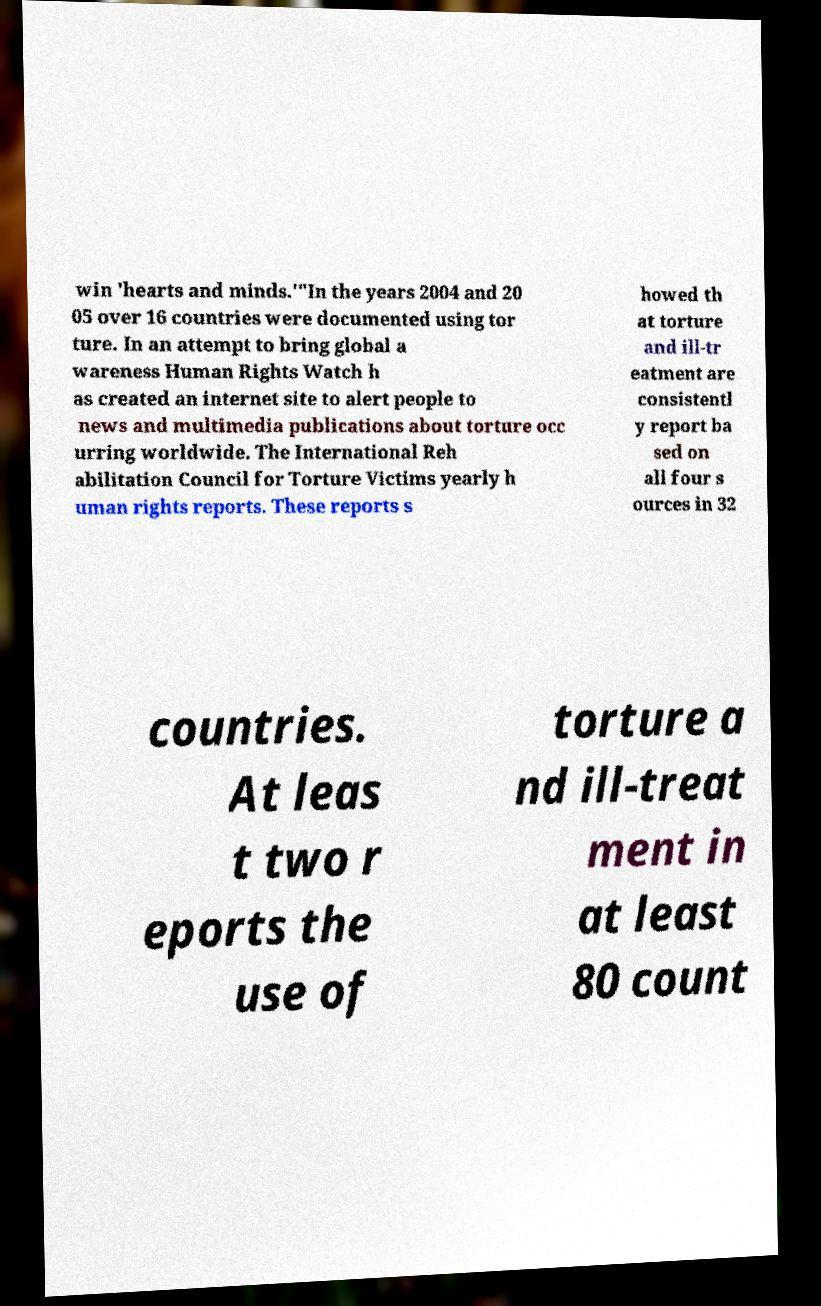Can you read and provide the text displayed in the image?This photo seems to have some interesting text. Can you extract and type it out for me? win 'hearts and minds.'"In the years 2004 and 20 05 over 16 countries were documented using tor ture. In an attempt to bring global a wareness Human Rights Watch h as created an internet site to alert people to news and multimedia publications about torture occ urring worldwide. The International Reh abilitation Council for Torture Victims yearly h uman rights reports. These reports s howed th at torture and ill-tr eatment are consistentl y report ba sed on all four s ources in 32 countries. At leas t two r eports the use of torture a nd ill-treat ment in at least 80 count 